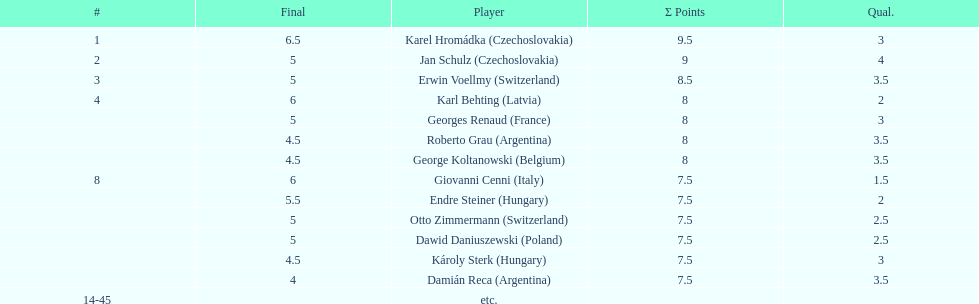Did the two competitors from hungary get more or less combined points than the two competitors from argentina? Less. 